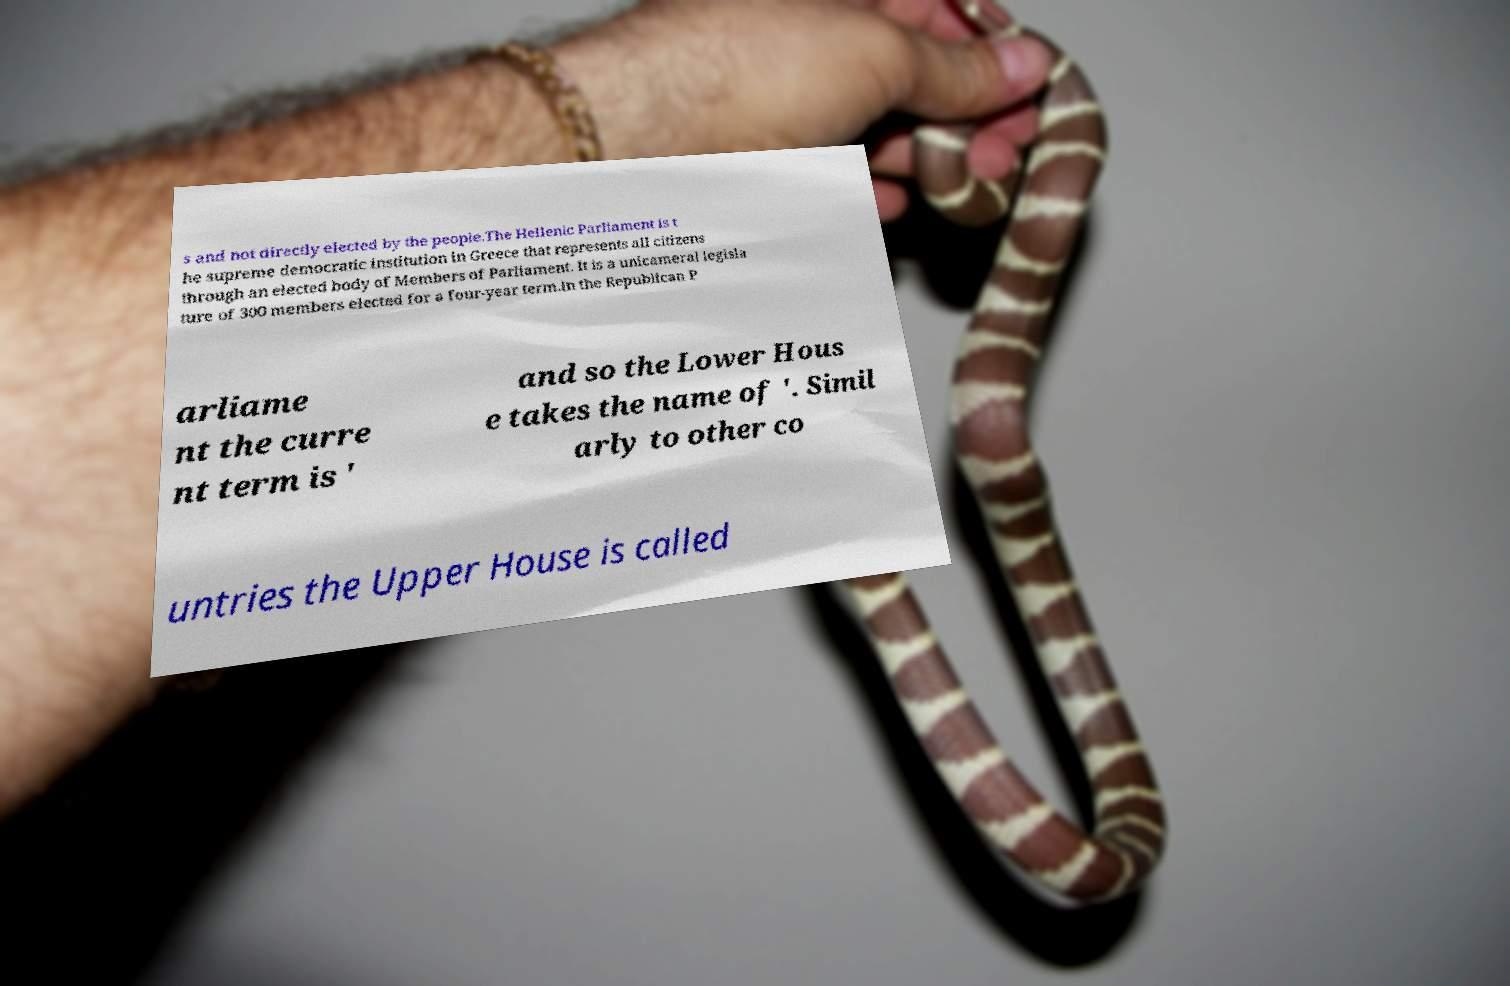What messages or text are displayed in this image? I need them in a readable, typed format. s and not directly elected by the people.The Hellenic Parliament is t he supreme democratic institution in Greece that represents all citizens through an elected body of Members of Parliament. It is a unicameral legisla ture of 300 members elected for a four-year term.In the Republican P arliame nt the curre nt term is ' and so the Lower Hous e takes the name of '. Simil arly to other co untries the Upper House is called 